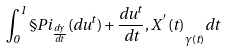<formula> <loc_0><loc_0><loc_500><loc_500>\int _ { 0 } ^ { 1 } \S P { i _ { \frac { d \gamma } { d t } } ( d u ^ { t } ) + \frac { d u ^ { t } } { d t } , X ^ { \, ^ { \prime } } ( t ) } _ { \gamma ( t ) } d t</formula> 